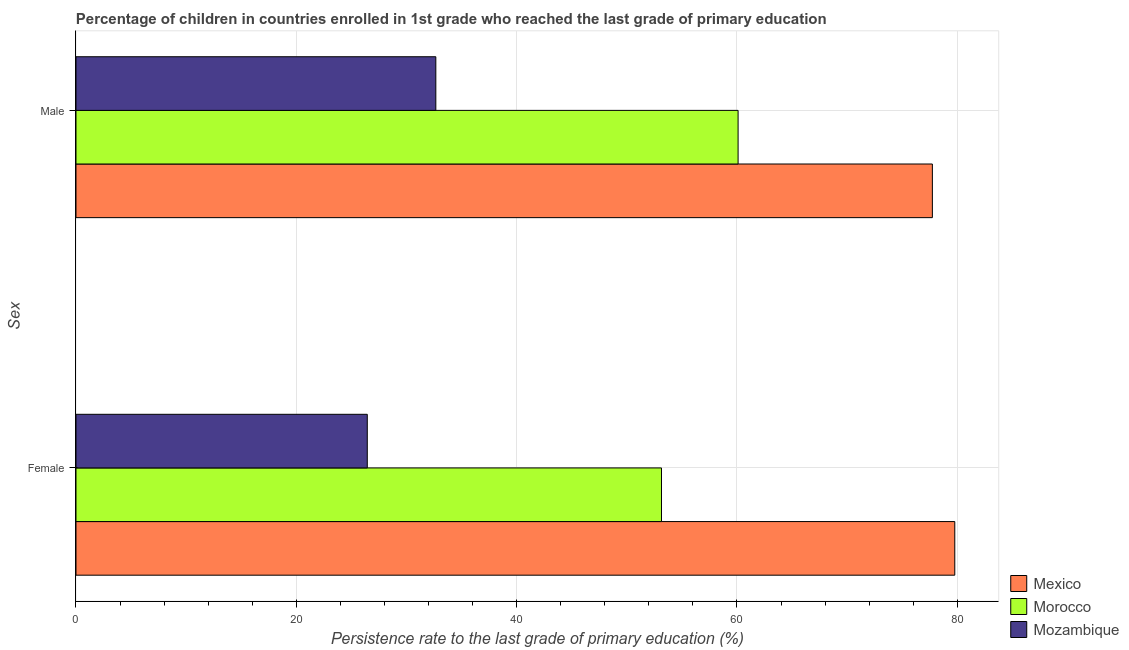How many groups of bars are there?
Make the answer very short. 2. Are the number of bars per tick equal to the number of legend labels?
Provide a succinct answer. Yes. Are the number of bars on each tick of the Y-axis equal?
Offer a terse response. Yes. How many bars are there on the 2nd tick from the top?
Offer a terse response. 3. What is the label of the 2nd group of bars from the top?
Ensure brevity in your answer.  Female. What is the persistence rate of male students in Mexico?
Offer a very short reply. 77.74. Across all countries, what is the maximum persistence rate of female students?
Provide a succinct answer. 79.77. Across all countries, what is the minimum persistence rate of female students?
Provide a succinct answer. 26.44. In which country was the persistence rate of female students maximum?
Provide a short and direct response. Mexico. In which country was the persistence rate of female students minimum?
Your response must be concise. Mozambique. What is the total persistence rate of female students in the graph?
Make the answer very short. 159.36. What is the difference between the persistence rate of female students in Morocco and that in Mexico?
Your response must be concise. -26.62. What is the difference between the persistence rate of male students in Morocco and the persistence rate of female students in Mexico?
Your response must be concise. -19.67. What is the average persistence rate of female students per country?
Make the answer very short. 53.12. What is the difference between the persistence rate of female students and persistence rate of male students in Morocco?
Make the answer very short. -6.95. In how many countries, is the persistence rate of female students greater than 48 %?
Provide a short and direct response. 2. What is the ratio of the persistence rate of male students in Mexico to that in Morocco?
Make the answer very short. 1.29. Is the persistence rate of female students in Mozambique less than that in Mexico?
Keep it short and to the point. Yes. What does the 2nd bar from the top in Male represents?
Give a very brief answer. Morocco. What does the 3rd bar from the bottom in Male represents?
Provide a short and direct response. Mozambique. Are all the bars in the graph horizontal?
Ensure brevity in your answer.  Yes. How many countries are there in the graph?
Ensure brevity in your answer.  3. How are the legend labels stacked?
Ensure brevity in your answer.  Vertical. What is the title of the graph?
Give a very brief answer. Percentage of children in countries enrolled in 1st grade who reached the last grade of primary education. Does "Caribbean small states" appear as one of the legend labels in the graph?
Keep it short and to the point. No. What is the label or title of the X-axis?
Offer a terse response. Persistence rate to the last grade of primary education (%). What is the label or title of the Y-axis?
Offer a terse response. Sex. What is the Persistence rate to the last grade of primary education (%) in Mexico in Female?
Your answer should be very brief. 79.77. What is the Persistence rate to the last grade of primary education (%) in Morocco in Female?
Offer a very short reply. 53.15. What is the Persistence rate to the last grade of primary education (%) in Mozambique in Female?
Keep it short and to the point. 26.44. What is the Persistence rate to the last grade of primary education (%) of Mexico in Male?
Keep it short and to the point. 77.74. What is the Persistence rate to the last grade of primary education (%) in Morocco in Male?
Ensure brevity in your answer.  60.1. What is the Persistence rate to the last grade of primary education (%) of Mozambique in Male?
Offer a terse response. 32.66. Across all Sex, what is the maximum Persistence rate to the last grade of primary education (%) of Mexico?
Your response must be concise. 79.77. Across all Sex, what is the maximum Persistence rate to the last grade of primary education (%) in Morocco?
Your response must be concise. 60.1. Across all Sex, what is the maximum Persistence rate to the last grade of primary education (%) of Mozambique?
Ensure brevity in your answer.  32.66. Across all Sex, what is the minimum Persistence rate to the last grade of primary education (%) of Mexico?
Your response must be concise. 77.74. Across all Sex, what is the minimum Persistence rate to the last grade of primary education (%) in Morocco?
Your answer should be very brief. 53.15. Across all Sex, what is the minimum Persistence rate to the last grade of primary education (%) in Mozambique?
Offer a terse response. 26.44. What is the total Persistence rate to the last grade of primary education (%) in Mexico in the graph?
Keep it short and to the point. 157.51. What is the total Persistence rate to the last grade of primary education (%) in Morocco in the graph?
Ensure brevity in your answer.  113.25. What is the total Persistence rate to the last grade of primary education (%) of Mozambique in the graph?
Offer a very short reply. 59.11. What is the difference between the Persistence rate to the last grade of primary education (%) in Mexico in Female and that in Male?
Make the answer very short. 2.03. What is the difference between the Persistence rate to the last grade of primary education (%) in Morocco in Female and that in Male?
Offer a very short reply. -6.95. What is the difference between the Persistence rate to the last grade of primary education (%) in Mozambique in Female and that in Male?
Offer a very short reply. -6.22. What is the difference between the Persistence rate to the last grade of primary education (%) of Mexico in Female and the Persistence rate to the last grade of primary education (%) of Morocco in Male?
Your answer should be very brief. 19.67. What is the difference between the Persistence rate to the last grade of primary education (%) in Mexico in Female and the Persistence rate to the last grade of primary education (%) in Mozambique in Male?
Give a very brief answer. 47.11. What is the difference between the Persistence rate to the last grade of primary education (%) in Morocco in Female and the Persistence rate to the last grade of primary education (%) in Mozambique in Male?
Provide a short and direct response. 20.48. What is the average Persistence rate to the last grade of primary education (%) of Mexico per Sex?
Your response must be concise. 78.75. What is the average Persistence rate to the last grade of primary education (%) of Morocco per Sex?
Provide a succinct answer. 56.62. What is the average Persistence rate to the last grade of primary education (%) of Mozambique per Sex?
Your answer should be very brief. 29.55. What is the difference between the Persistence rate to the last grade of primary education (%) of Mexico and Persistence rate to the last grade of primary education (%) of Morocco in Female?
Offer a very short reply. 26.62. What is the difference between the Persistence rate to the last grade of primary education (%) of Mexico and Persistence rate to the last grade of primary education (%) of Mozambique in Female?
Provide a short and direct response. 53.33. What is the difference between the Persistence rate to the last grade of primary education (%) of Morocco and Persistence rate to the last grade of primary education (%) of Mozambique in Female?
Provide a succinct answer. 26.71. What is the difference between the Persistence rate to the last grade of primary education (%) of Mexico and Persistence rate to the last grade of primary education (%) of Morocco in Male?
Make the answer very short. 17.63. What is the difference between the Persistence rate to the last grade of primary education (%) in Mexico and Persistence rate to the last grade of primary education (%) in Mozambique in Male?
Your answer should be very brief. 45.07. What is the difference between the Persistence rate to the last grade of primary education (%) in Morocco and Persistence rate to the last grade of primary education (%) in Mozambique in Male?
Provide a succinct answer. 27.44. What is the ratio of the Persistence rate to the last grade of primary education (%) of Mexico in Female to that in Male?
Provide a succinct answer. 1.03. What is the ratio of the Persistence rate to the last grade of primary education (%) in Morocco in Female to that in Male?
Make the answer very short. 0.88. What is the ratio of the Persistence rate to the last grade of primary education (%) in Mozambique in Female to that in Male?
Your response must be concise. 0.81. What is the difference between the highest and the second highest Persistence rate to the last grade of primary education (%) in Mexico?
Make the answer very short. 2.03. What is the difference between the highest and the second highest Persistence rate to the last grade of primary education (%) of Morocco?
Keep it short and to the point. 6.95. What is the difference between the highest and the second highest Persistence rate to the last grade of primary education (%) in Mozambique?
Provide a short and direct response. 6.22. What is the difference between the highest and the lowest Persistence rate to the last grade of primary education (%) of Mexico?
Ensure brevity in your answer.  2.03. What is the difference between the highest and the lowest Persistence rate to the last grade of primary education (%) in Morocco?
Make the answer very short. 6.95. What is the difference between the highest and the lowest Persistence rate to the last grade of primary education (%) of Mozambique?
Provide a short and direct response. 6.22. 